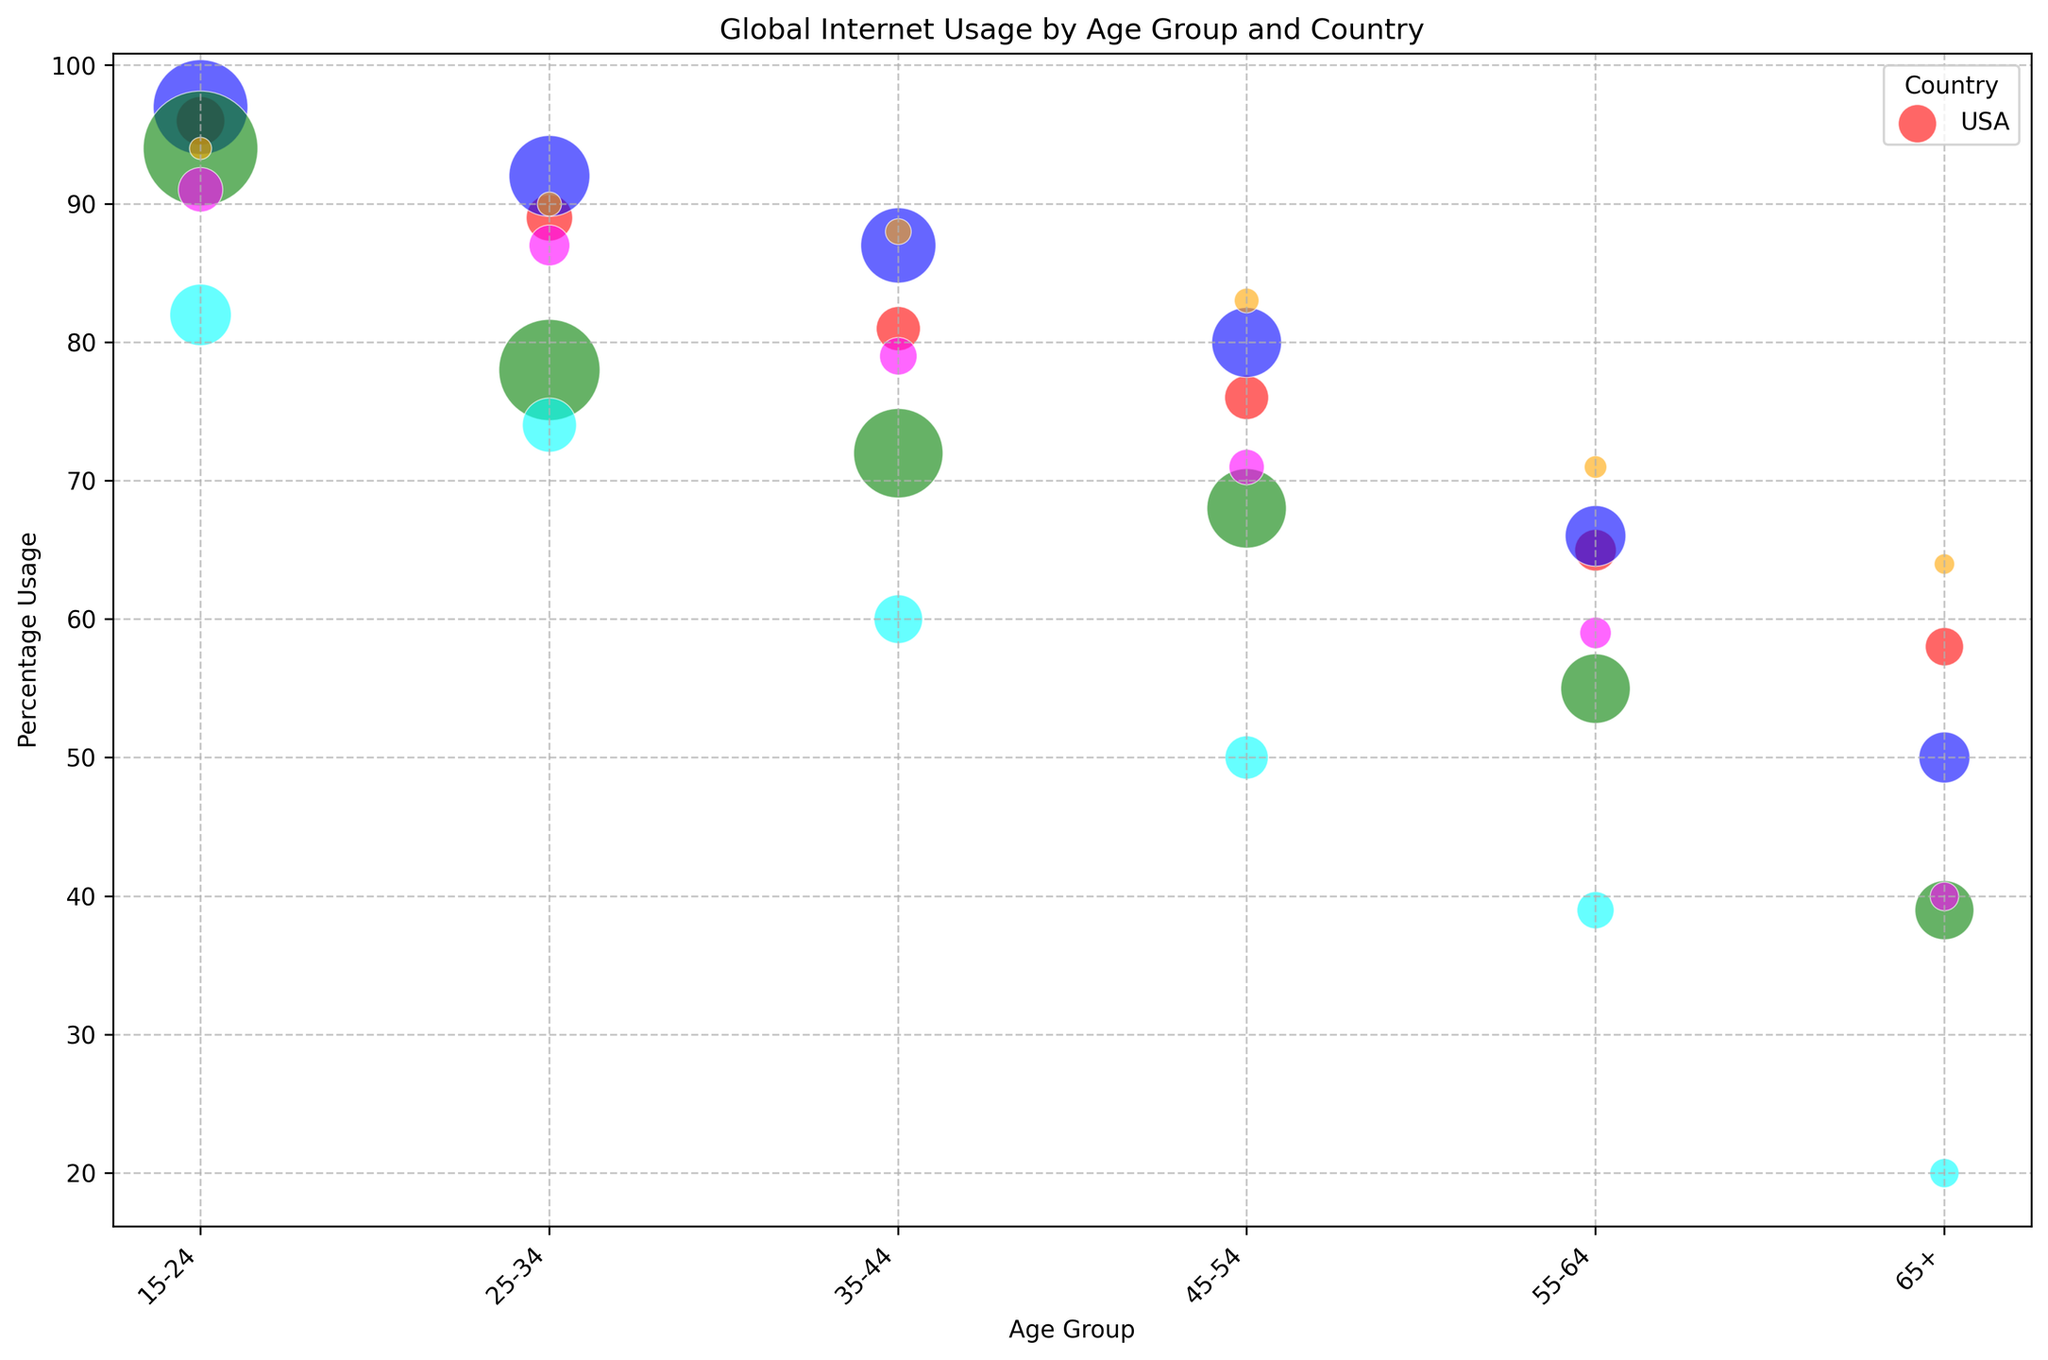What country shows the highest percentage of internet usage among the 15-24 age group? By observing the color-coding and the position of the bubbles for the 15-24 age group, the highest bubble indicates the country with the highest percentage. The blue bubble (China) is at the highest position, indicating the highest usage.
Answer: China Which age group in the USA has the lowest percentage of internet usage? Looking at the red bubbles representing the USA, the bubble with the lowest position indicates the least usage. The 65+ age group has the lowest percentage.
Answer: 65+ Between Germany and India, which country shows higher internet usage for the 25-34 age group? Comparing the orange bubble (Germany) and the green bubble (India) for the 25-34 age group, the higher bubble represents higher usage. The orange bubble (Germany) is higher than the green bubble (India).
Answer: Germany Which country has the largest bubble for the 55-64 age group, and what does it represent? The largest bubble size indicates the highest population in that age group. For the 55-64 age group, the largest bubble is green (India). This represents that India has the highest population in that age group.
Answer: India Compare the internet usage percentage between 15-24 and 65+ age groups in Brazil. What is the difference? Observing the magenta bubbles for Brazil, the percentage usage for 15-24 is 91% and for 65+ is 40%. The difference is 91 - 40 = 51.
Answer: 51 Which country among the listed shows the lowest internet usage percentage for the 65+ age group? By looking at the bubbles in the 65+ age group, the lowest position represents the lowest usage. The cyan bubble (Nigeria) is the lowest.
Answer: Nigeria What is the average internet usage percentage for the 35-44 age group across all countries? Summarize the percentage usage for the 35-44 age group across all countries: (81 + 87 + 72 + 79 + 88 + 60) = 467. Divide by the number of countries, 467 / 6 gives about 77.83.
Answer: 77.83 In which country does the 45-54 age group have a higher percentage of internet usage than the 55-64 age group? Observe the bubbles for 45-54 and 55-64 age groups, and compare their heights. The countries where 45-54 has higher usage than 55-64 include USA, China, India, Brazil, Germany, and Nigeria.
Answer: All listed countries What is the difference in the internet usage percentage between the highest and lowest usage countries for the 15-24 age group? Identify the highest (China, 97%) and the lowest (Nigeria, 82%) usage percentages for the 15-24 age group. The difference is 97 - 82 = 15.
Answer: 15 Which two age groups in China have the closest internet usage percentages? Comparing the bubbles for China, 55-64 and 45-54 have the closest percentages with 66% and 80% respectively, giving a difference of 14.
Answer: 55-64 and 45-54 